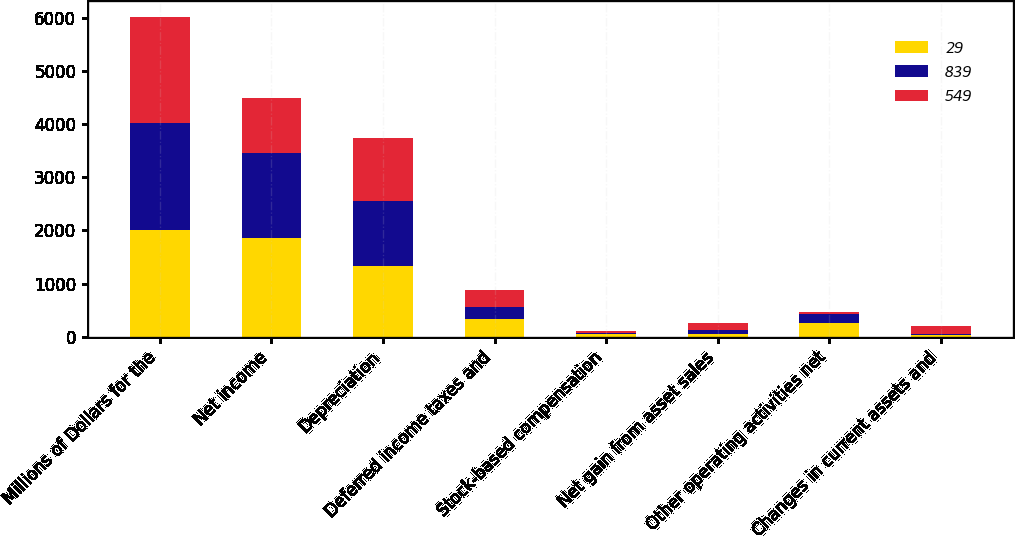Convert chart to OTSL. <chart><loc_0><loc_0><loc_500><loc_500><stacked_bar_chart><ecel><fcel>Millions of Dollars for the<fcel>Net income<fcel>Depreciation<fcel>Deferred income taxes and<fcel>Stock-based compensation<fcel>Net gain from asset sales<fcel>Other operating activities net<fcel>Changes in current assets and<nl><fcel>29<fcel>2007<fcel>1855<fcel>1321<fcel>332<fcel>44<fcel>52<fcel>251<fcel>28<nl><fcel>839<fcel>2006<fcel>1606<fcel>1237<fcel>235<fcel>35<fcel>72<fcel>175<fcel>14<nl><fcel>549<fcel>2005<fcel>1026<fcel>1175<fcel>320<fcel>21<fcel>135<fcel>37<fcel>151<nl></chart> 